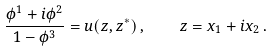<formula> <loc_0><loc_0><loc_500><loc_500>\frac { \phi ^ { 1 } + i \phi ^ { 2 } } { 1 - \phi ^ { 3 } } = u ( z , z ^ { * } ) \, , \quad z = x _ { 1 } + i x _ { 2 } \, .</formula> 